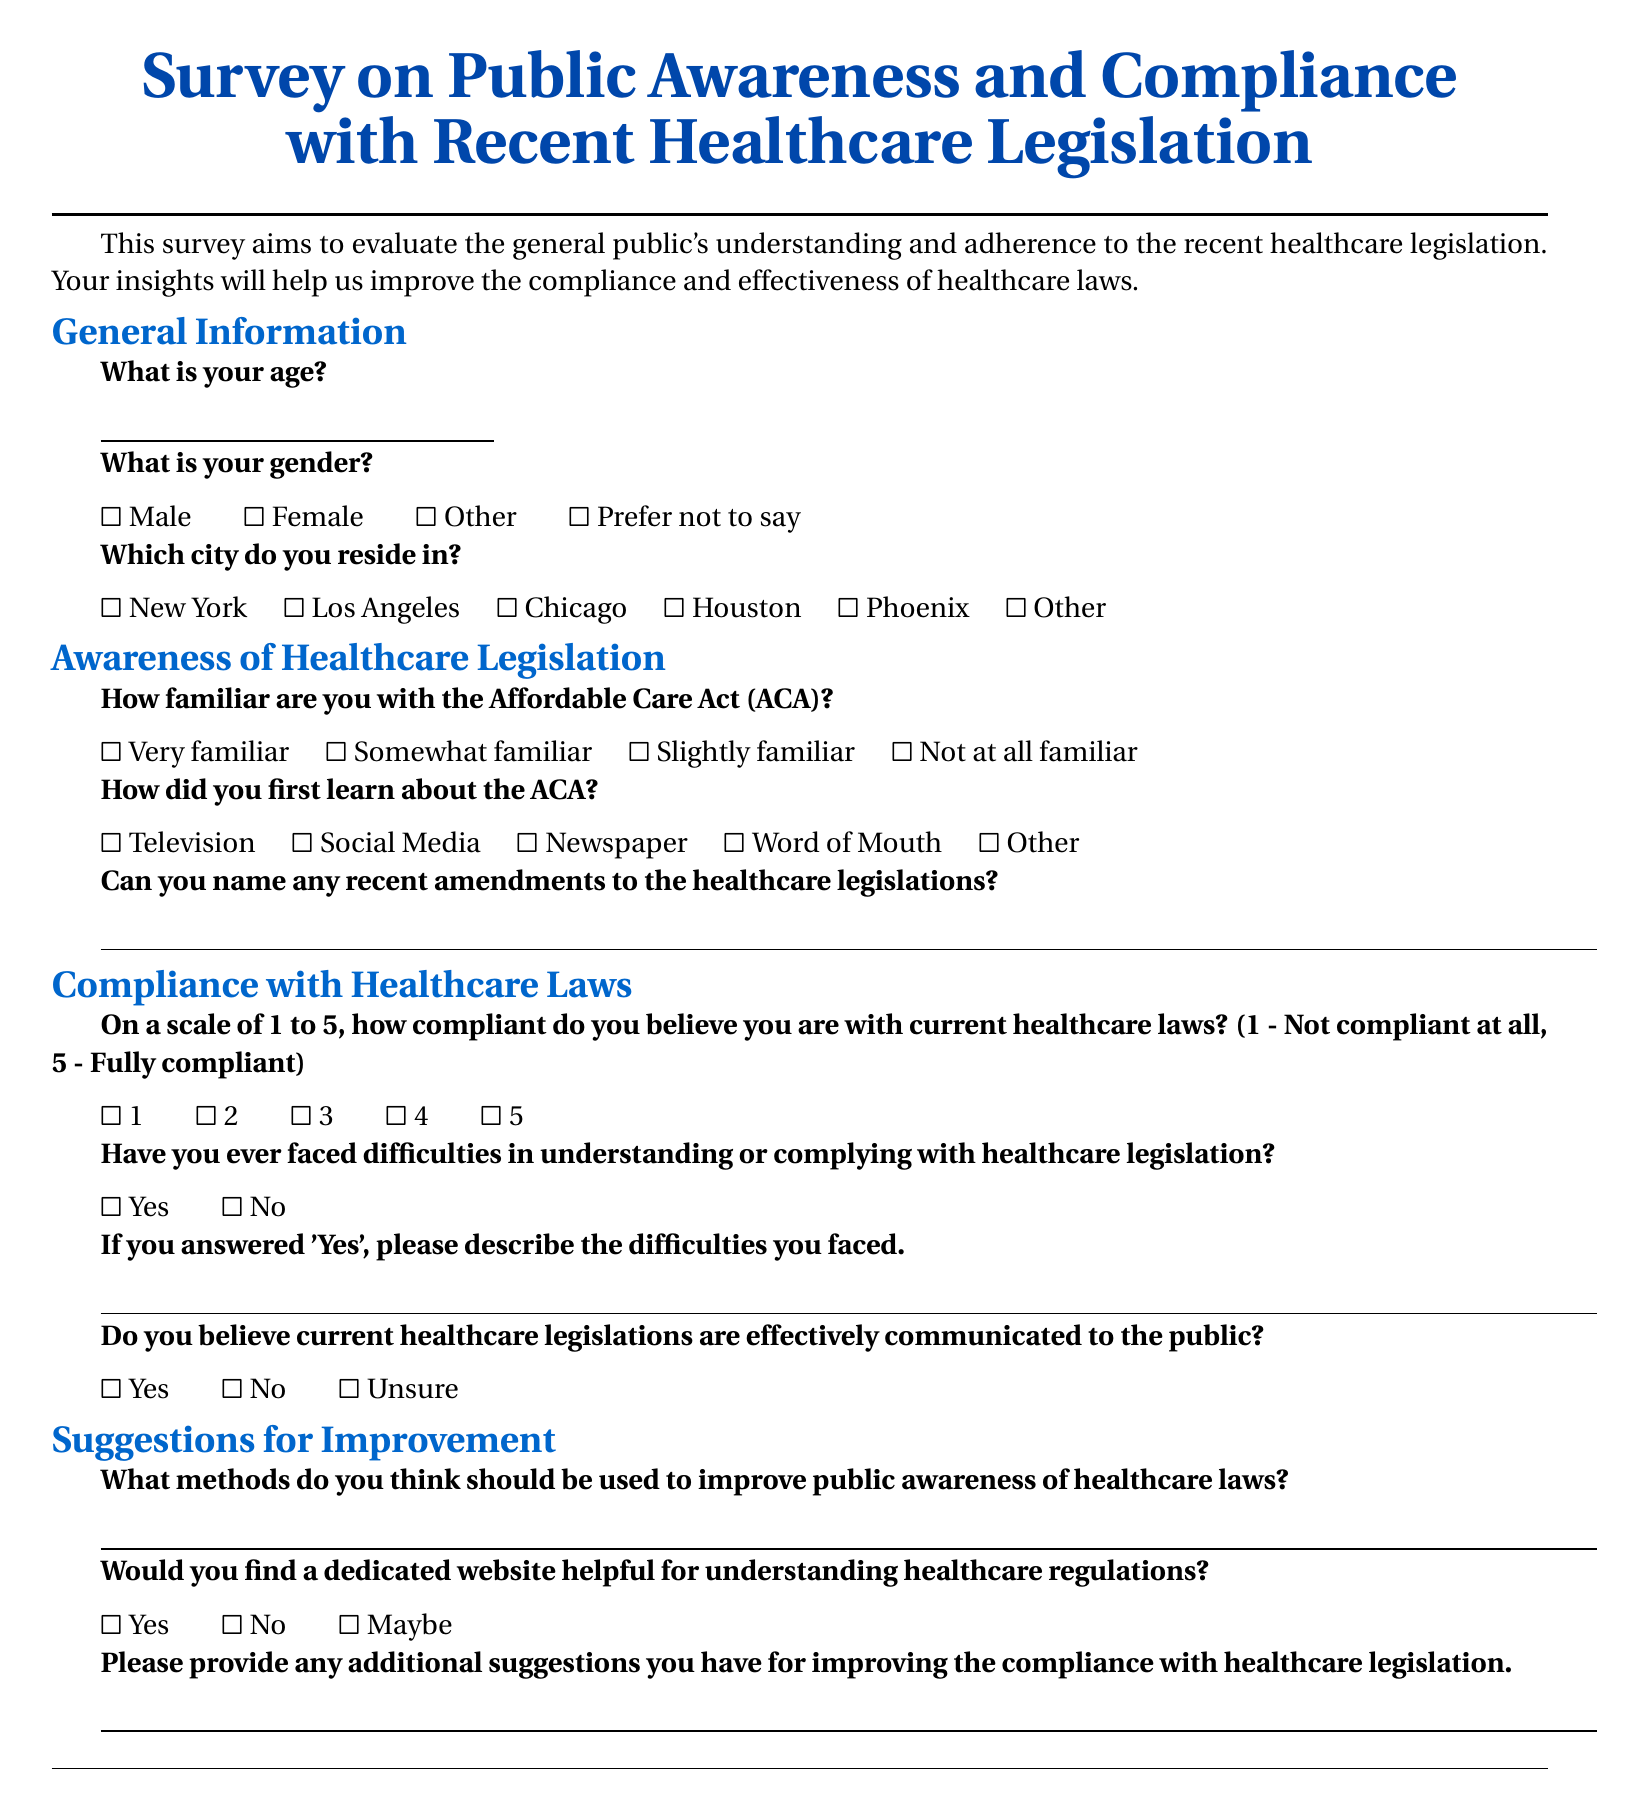What is the title of the survey? The title is presented at the beginning of the document and reads "Survey on Public Awareness and Compliance with Recent Healthcare Legislation."
Answer: Survey on Public Awareness and Compliance with Recent Healthcare Legislation What are the four options available for gender? The document lists four options the respondents can choose from regarding gender.
Answer: Male, Female, Other, Prefer not to say What does the survey aim to evaluate? The document states that the survey aims to evaluate the general public's understanding and adherence to recent healthcare legislation.
Answer: Public's understanding and adherence to recent healthcare legislation How many familiarity levels are included for the Affordable Care Act? The survey provides four different levels to choose from regarding familiarity with the ACA.
Answer: Four What is the highest rating on the compliance scale? The document includes a scale from 1 to 5 for respondents to rate their compliance with current healthcare laws.
Answer: 5 What type of questions are included under "Suggestions for Improvement"? The section is focused on gathering suggestions from respondents regarding improving public awareness and compliance with healthcare laws.
Answer: Open-ended questions Have participants been asked to describe difficulties they faced? The survey includes a question specifically asking respondents to describe any difficulties they faced in understanding or complying with healthcare legislation.
Answer: Yes Is there a question about finding a dedicated website helpful? The document explicitly asks if a dedicated website would be helpful for understanding healthcare regulations.
Answer: Yes 